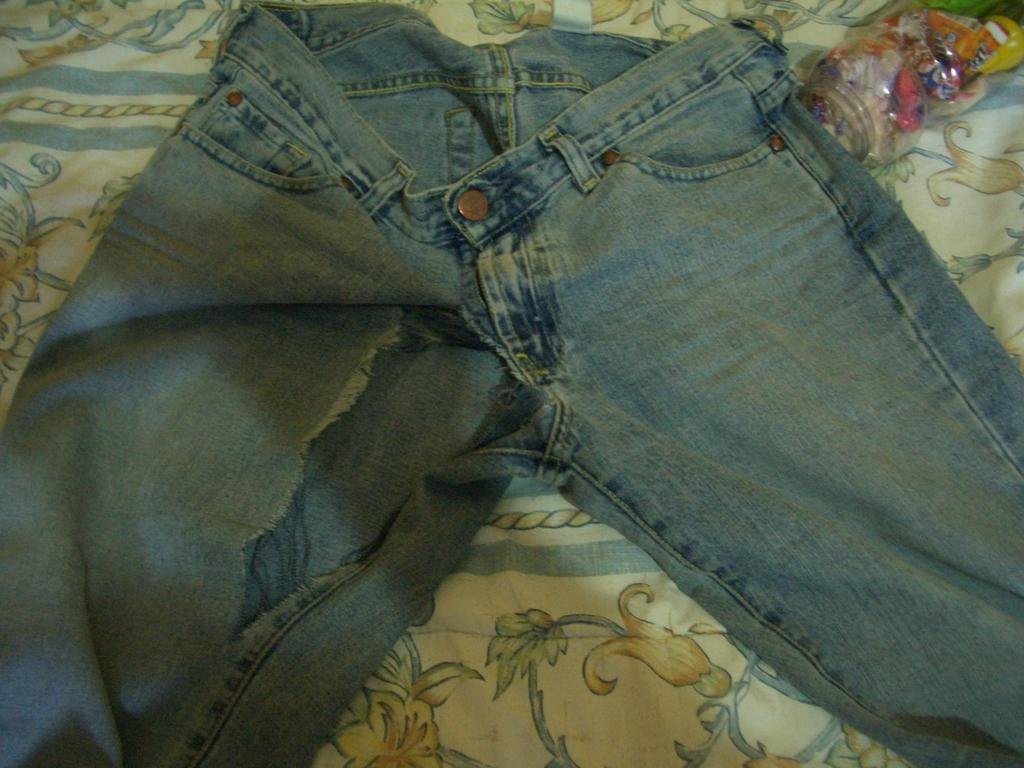What type of clothing is on the bed in the image? There is a pair of blue jeans on the bed. What is covering the bed in the image? There is a plastic cover on the bed. What is at the bottom of the bed in the image? There is a bed sheet at the bottom of the bed. Reasoning: Let's let's think step by step in order to produce the conversation. We start by identifying the main subjects and objects in the image based on the provided facts. We then formulate questions that focus on the location and characteristics of these subjects and objects, ensuring that each question can be answered definitively with the information given. We avoid yes/no questions and ensure that the language is simple and clear. Absurd Question/Answer: Can you see a zebra at the seashore in the image? No, there is no zebra or seashore present in the image. What type of steel object is visible in the image? There is no steel object present in the image. 